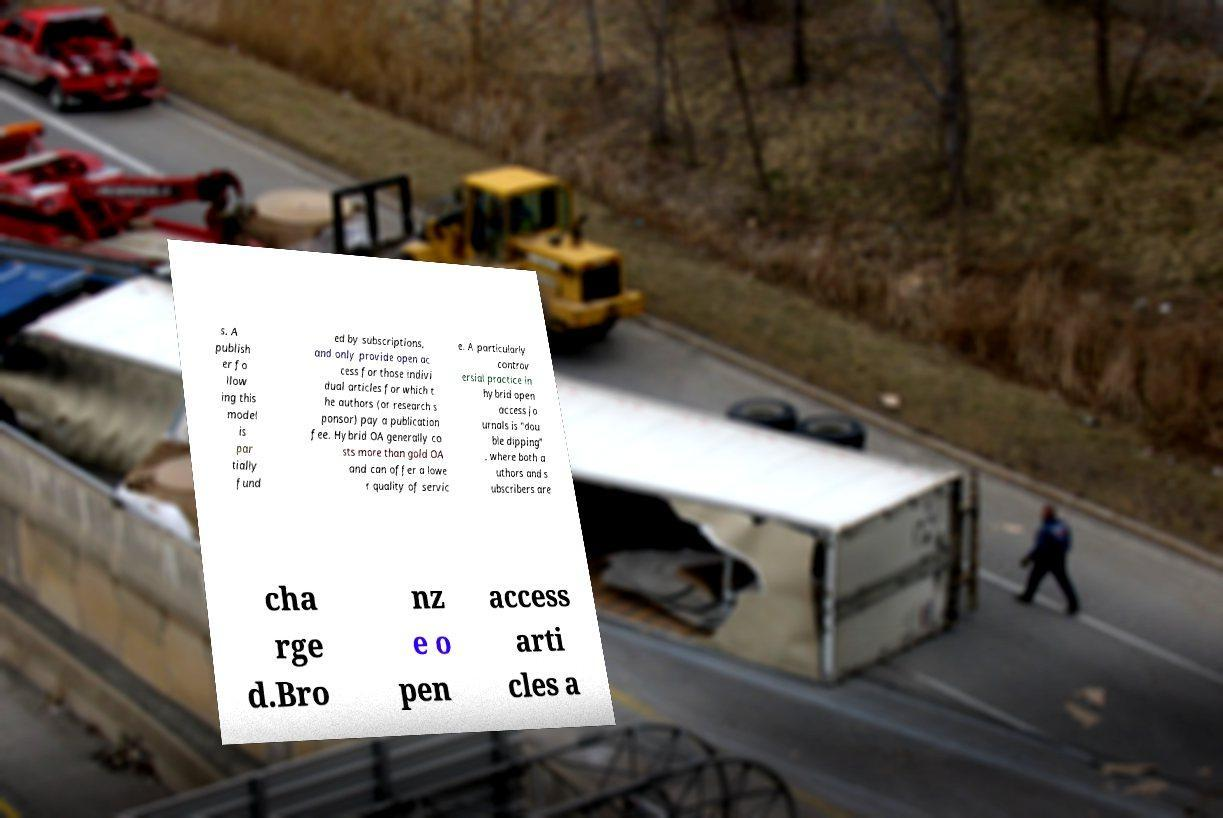Could you assist in decoding the text presented in this image and type it out clearly? s. A publish er fo llow ing this model is par tially fund ed by subscriptions, and only provide open ac cess for those indivi dual articles for which t he authors (or research s ponsor) pay a publication fee. Hybrid OA generally co sts more than gold OA and can offer a lowe r quality of servic e. A particularly controv ersial practice in hybrid open access jo urnals is "dou ble dipping" , where both a uthors and s ubscribers are cha rge d.Bro nz e o pen access arti cles a 